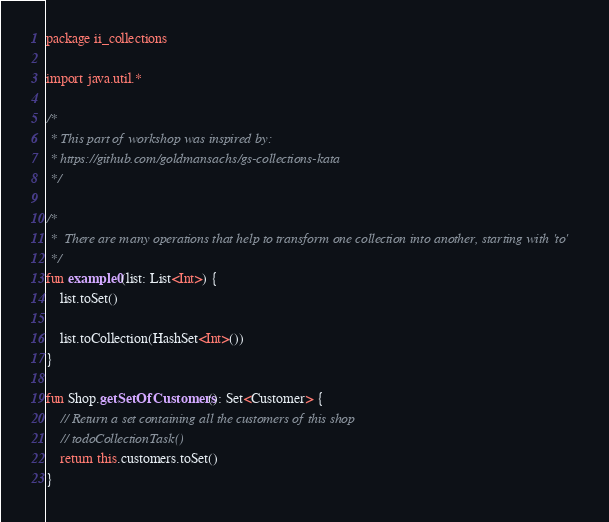<code> <loc_0><loc_0><loc_500><loc_500><_Kotlin_>package ii_collections

import java.util.*

/*
 * This part of workshop was inspired by:
 * https://github.com/goldmansachs/gs-collections-kata
 */

/*
 *  There are many operations that help to transform one collection into another, starting with 'to'
 */
fun example0(list: List<Int>) {
    list.toSet()

    list.toCollection(HashSet<Int>())
}

fun Shop.getSetOfCustomers(): Set<Customer> {
    // Return a set containing all the customers of this shop
    // todoCollectionTask()
    return this.customers.toSet()
}

</code> 